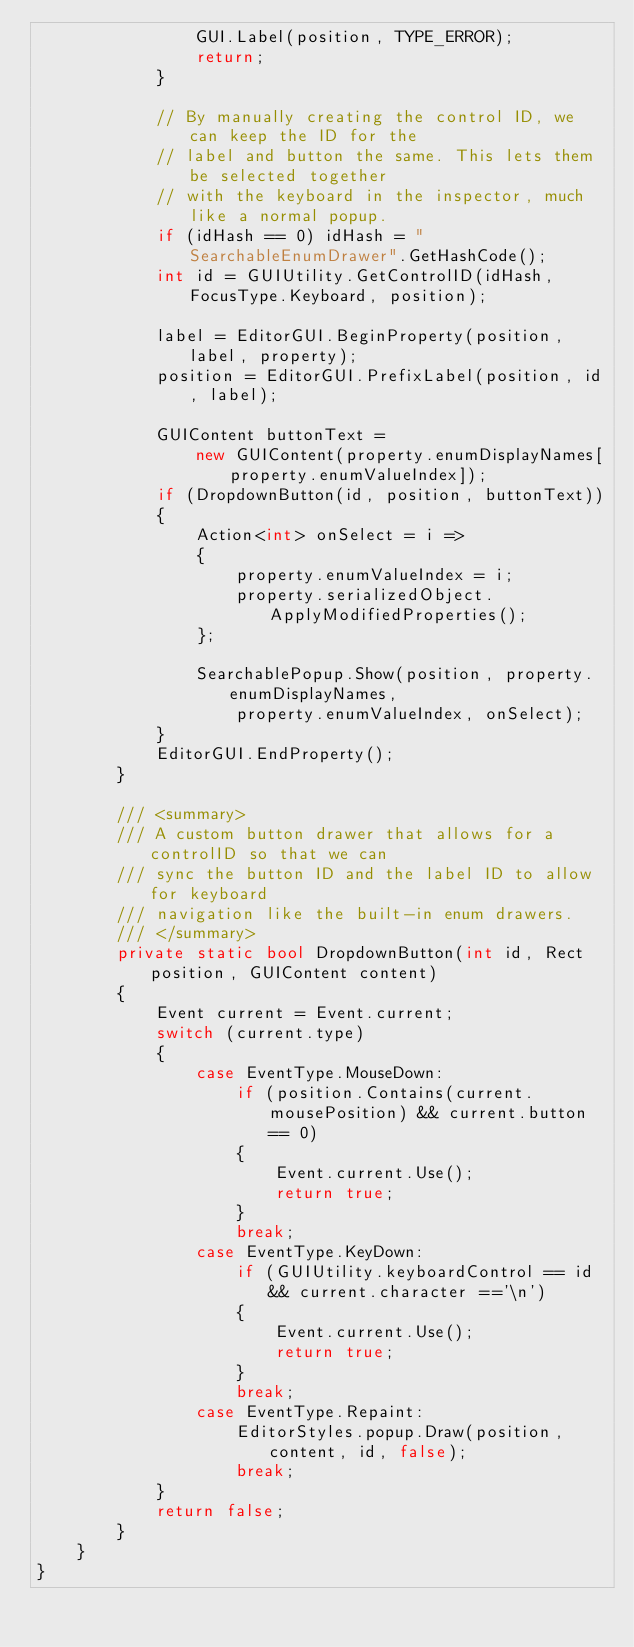Convert code to text. <code><loc_0><loc_0><loc_500><loc_500><_C#_>                GUI.Label(position, TYPE_ERROR);
                return;
            }
            
            // By manually creating the control ID, we can keep the ID for the
            // label and button the same. This lets them be selected together
            // with the keyboard in the inspector, much like a normal popup.
            if (idHash == 0) idHash = "SearchableEnumDrawer".GetHashCode();
            int id = GUIUtility.GetControlID(idHash, FocusType.Keyboard, position);
            
            label = EditorGUI.BeginProperty(position, label, property);
            position = EditorGUI.PrefixLabel(position, id, label);

            GUIContent buttonText = 
                new GUIContent(property.enumDisplayNames[property.enumValueIndex]);
            if (DropdownButton(id, position, buttonText))
            {
                Action<int> onSelect = i =>
                {
                    property.enumValueIndex = i;
                    property.serializedObject.ApplyModifiedProperties();
                };
                
                SearchablePopup.Show(position, property.enumDisplayNames,
                    property.enumValueIndex, onSelect);
            }
            EditorGUI.EndProperty();
        }
        
        /// <summary>
        /// A custom button drawer that allows for a controlID so that we can
        /// sync the button ID and the label ID to allow for keyboard
        /// navigation like the built-in enum drawers.
        /// </summary>
        private static bool DropdownButton(int id, Rect position, GUIContent content)
        {
            Event current = Event.current;
            switch (current.type)
            {
                case EventType.MouseDown:
                    if (position.Contains(current.mousePosition) && current.button == 0)
                    {
                        Event.current.Use();
                        return true;
                    }
                    break;
                case EventType.KeyDown:
                    if (GUIUtility.keyboardControl == id && current.character =='\n')
                    {
                        Event.current.Use();
                        return true;
                    }
                    break;
                case EventType.Repaint:
                    EditorStyles.popup.Draw(position, content, id, false);
                    break;
            }
            return false;
        }
    }
}
</code> 